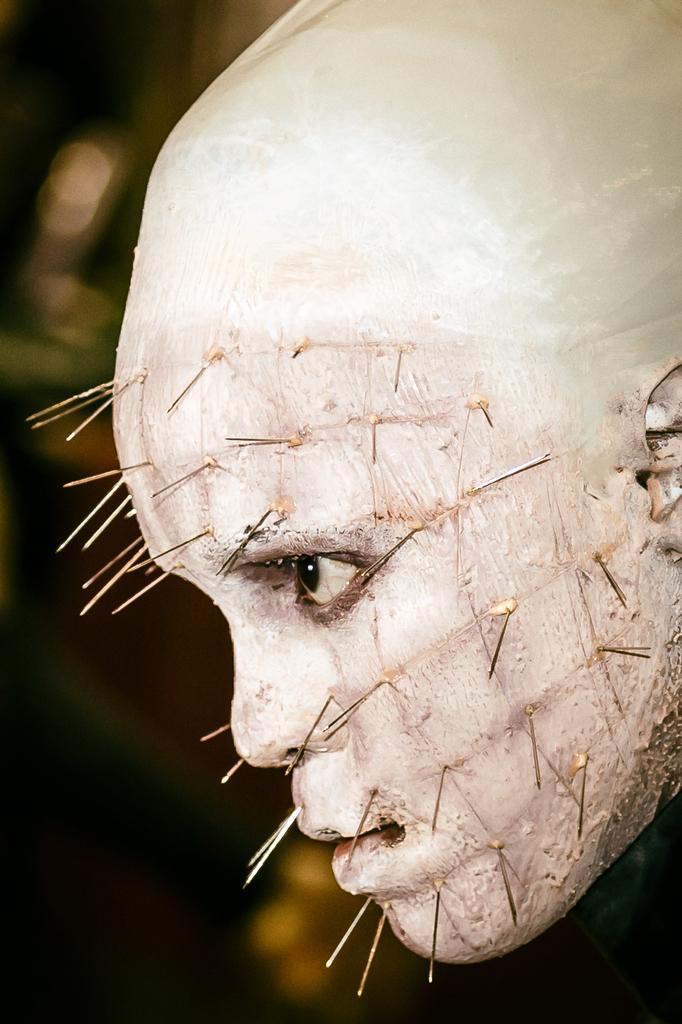Can you describe this image briefly? In this picture there is a man's face towards the right. On the face their needles are attached. 